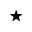<formula> <loc_0><loc_0><loc_500><loc_500>^ { ^ { * } }</formula> 